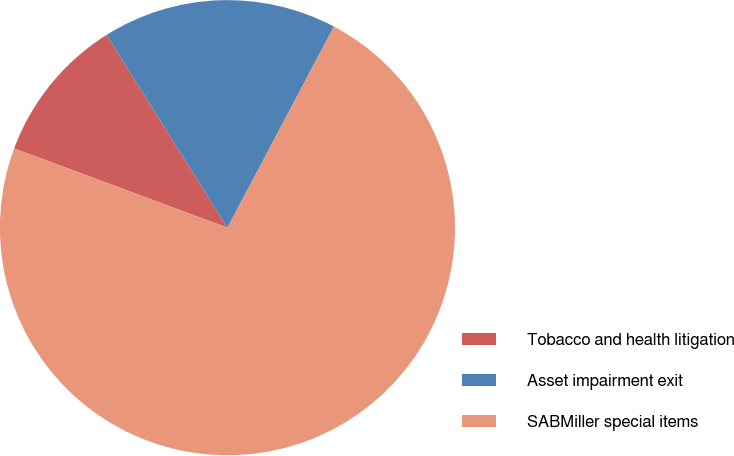Convert chart. <chart><loc_0><loc_0><loc_500><loc_500><pie_chart><fcel>Tobacco and health litigation<fcel>Asset impairment exit<fcel>SABMiller special items<nl><fcel>10.42%<fcel>16.67%<fcel>72.92%<nl></chart> 